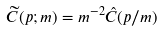Convert formula to latex. <formula><loc_0><loc_0><loc_500><loc_500>\widetilde { C } ( p ; m ) = m ^ { - 2 } \hat { C } ( p / m )</formula> 